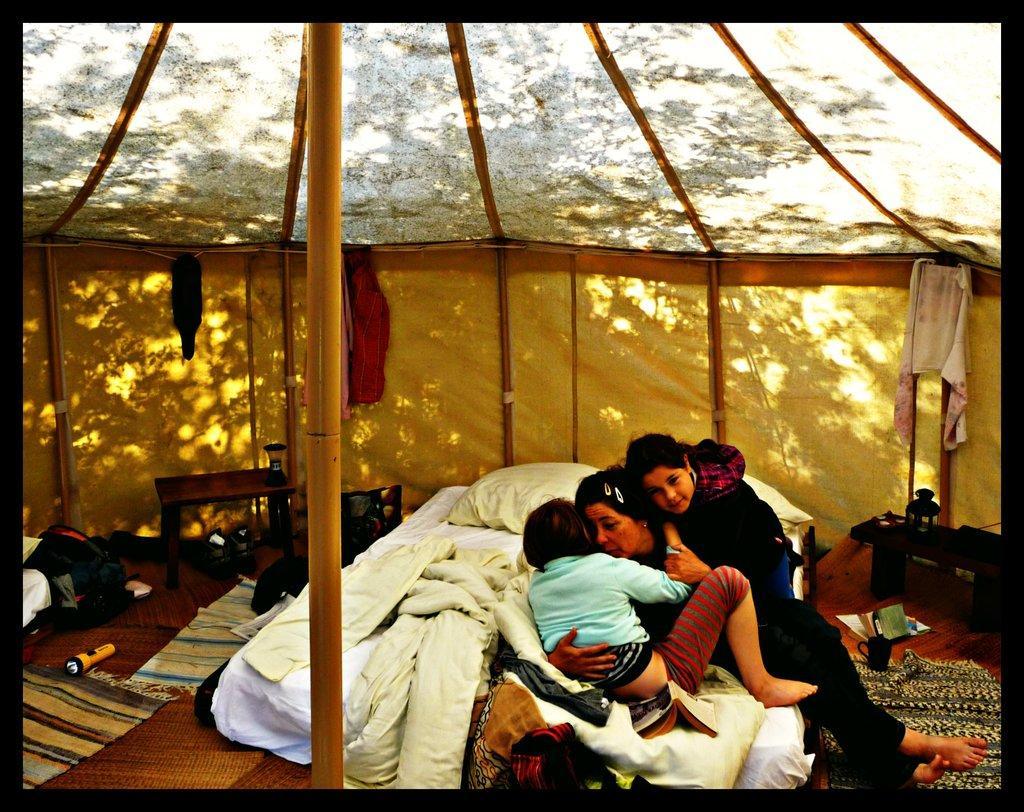Describe this image in one or two sentences. In this picture we can see a women and two babies laid on the bed and on the bed we can see blanket , pillows. this is a torch, table, lantern, cup, books. We can see few clothes hanged here. 